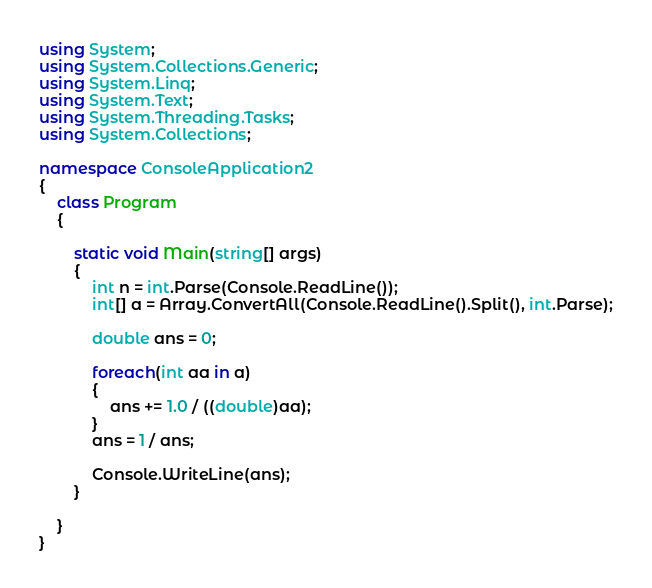<code> <loc_0><loc_0><loc_500><loc_500><_C#_>using System;
using System.Collections.Generic;
using System.Linq;
using System.Text;
using System.Threading.Tasks;
using System.Collections;

namespace ConsoleApplication2
{
    class Program
    {

        static void Main(string[] args)
        {
            int n = int.Parse(Console.ReadLine());
            int[] a = Array.ConvertAll(Console.ReadLine().Split(), int.Parse);

            double ans = 0;

            foreach(int aa in a)
            {
                ans += 1.0 / ((double)aa);
            }
            ans = 1 / ans;

            Console.WriteLine(ans);
        }

    }
}</code> 